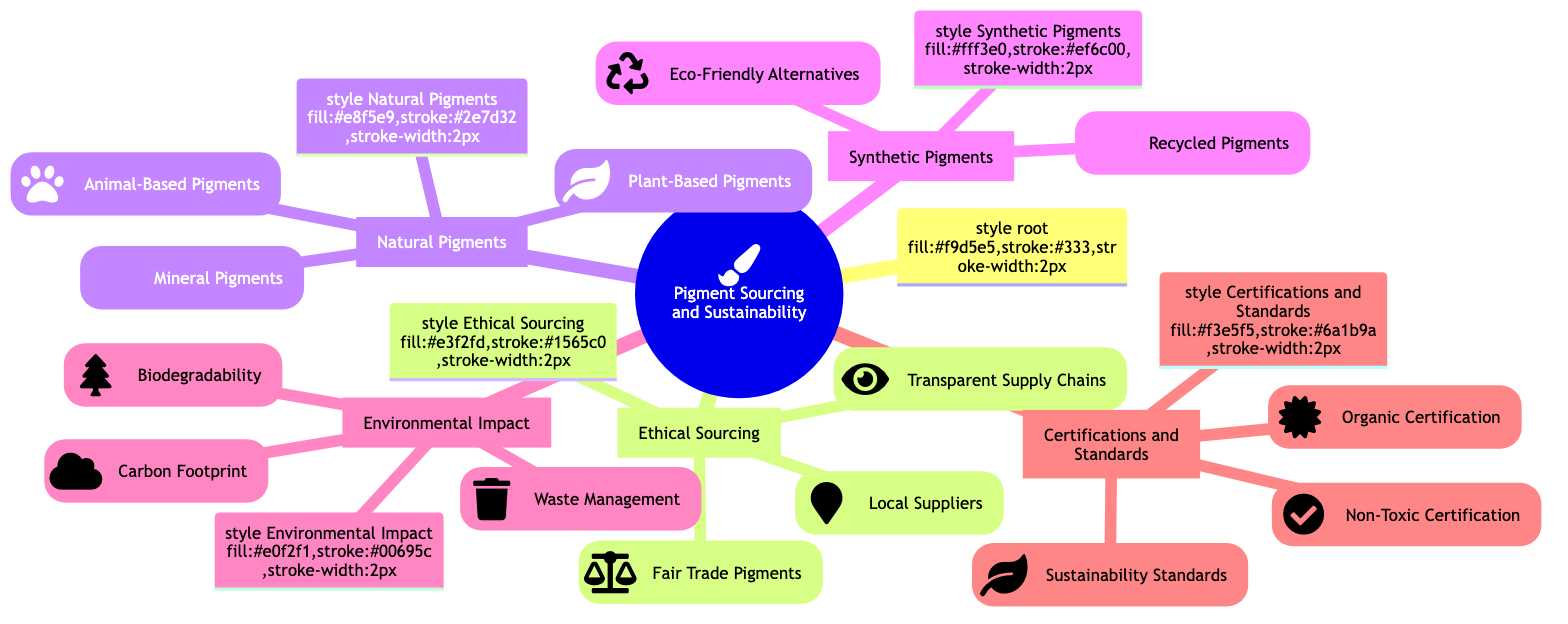What are two types of natural pigments mentioned? The node for "Natural Pigments" has three subcategories—Mineral Pigments, Plant-Based Pigments, and Animal-Based Pigments. Therefore, any combination of two from these three (e.g., Mineral and Plant-Based) qualifies as the answer.
Answer: Mineral Pigments, Plant-Based Pigments How many local suppliers are listed? The "Local Suppliers" sub-node under "Ethical Sourcing" lists two specific suppliers: Earth Pigments Company and Natural Earth Paint. Counting these gives the total of 2 local suppliers.
Answer: 2 Which certification is related to non-toxic products? Within the "Certifications and Standards" section, the "Non-Toxic Certification" node lists specific certifications. The AP Seal from ACMI and the EN71 Safety Standard are associated with non-toxic products. Therefore, any of these can be a valid answer.
Answer: AP Seal from ACMI What are the eco-friendly alternatives for synthetic pigments? In the "Synthetic Pigments" section, the sub-node "Eco-Friendly Alternatives" lists two options: Non-Toxic Acrylics and Soy-Based Paints. Either of these effectively answers the question.
Answer: Non-Toxic Acrylics Which category includes Cochineal? In the "Natural Pigments" section, the sub-category "Animal-Based Pigments" specifically lists Cochineal as one of its examples. This direct reference leads to the answer.
Answer: Natural Pigments How many waste management strategies are mentioned? The "Waste Management" sub-node under "Environmental Impact" includes two specific strategies: Recycling Paint Containers and Safe Disposal Methods. Thus, there are 2 strategies listed in this section.
Answer: 2 What type of pigments does "GLOB" represent? Under "Ethical Sourcing," the "Fair Trade Pigments" sub-node lists GLOB. This indicates that GLOB is a type of Fair Trade pigment. Therefore, the type associated with GLOB is deduced clearly.
Answer: Fair Trade Pigment Which color indicates the "Environmental Impact" category? The "Environmental Impact" node is filled with a specific color, which is identified in the diagram as a light teal shade with the code #e0f2f1. Thus, the color representing this category is directly referenced.
Answer: Light teal What two factors are considered under environmental impact? The "Environmental Impact" section has three subcategories: Biodegradability, Carbon Footprint, and Waste Management. Any two factors from this list will suffice as an answer, as they all pertain to environmental impact.
Answer: Biodegradability, Carbon Footprint 